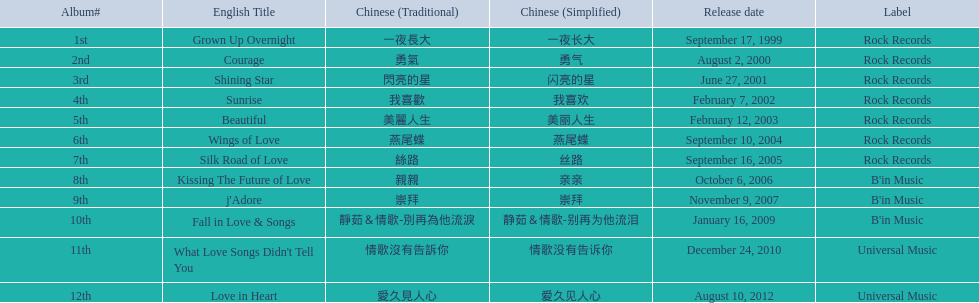How many songs are there on rock albums? 7. 